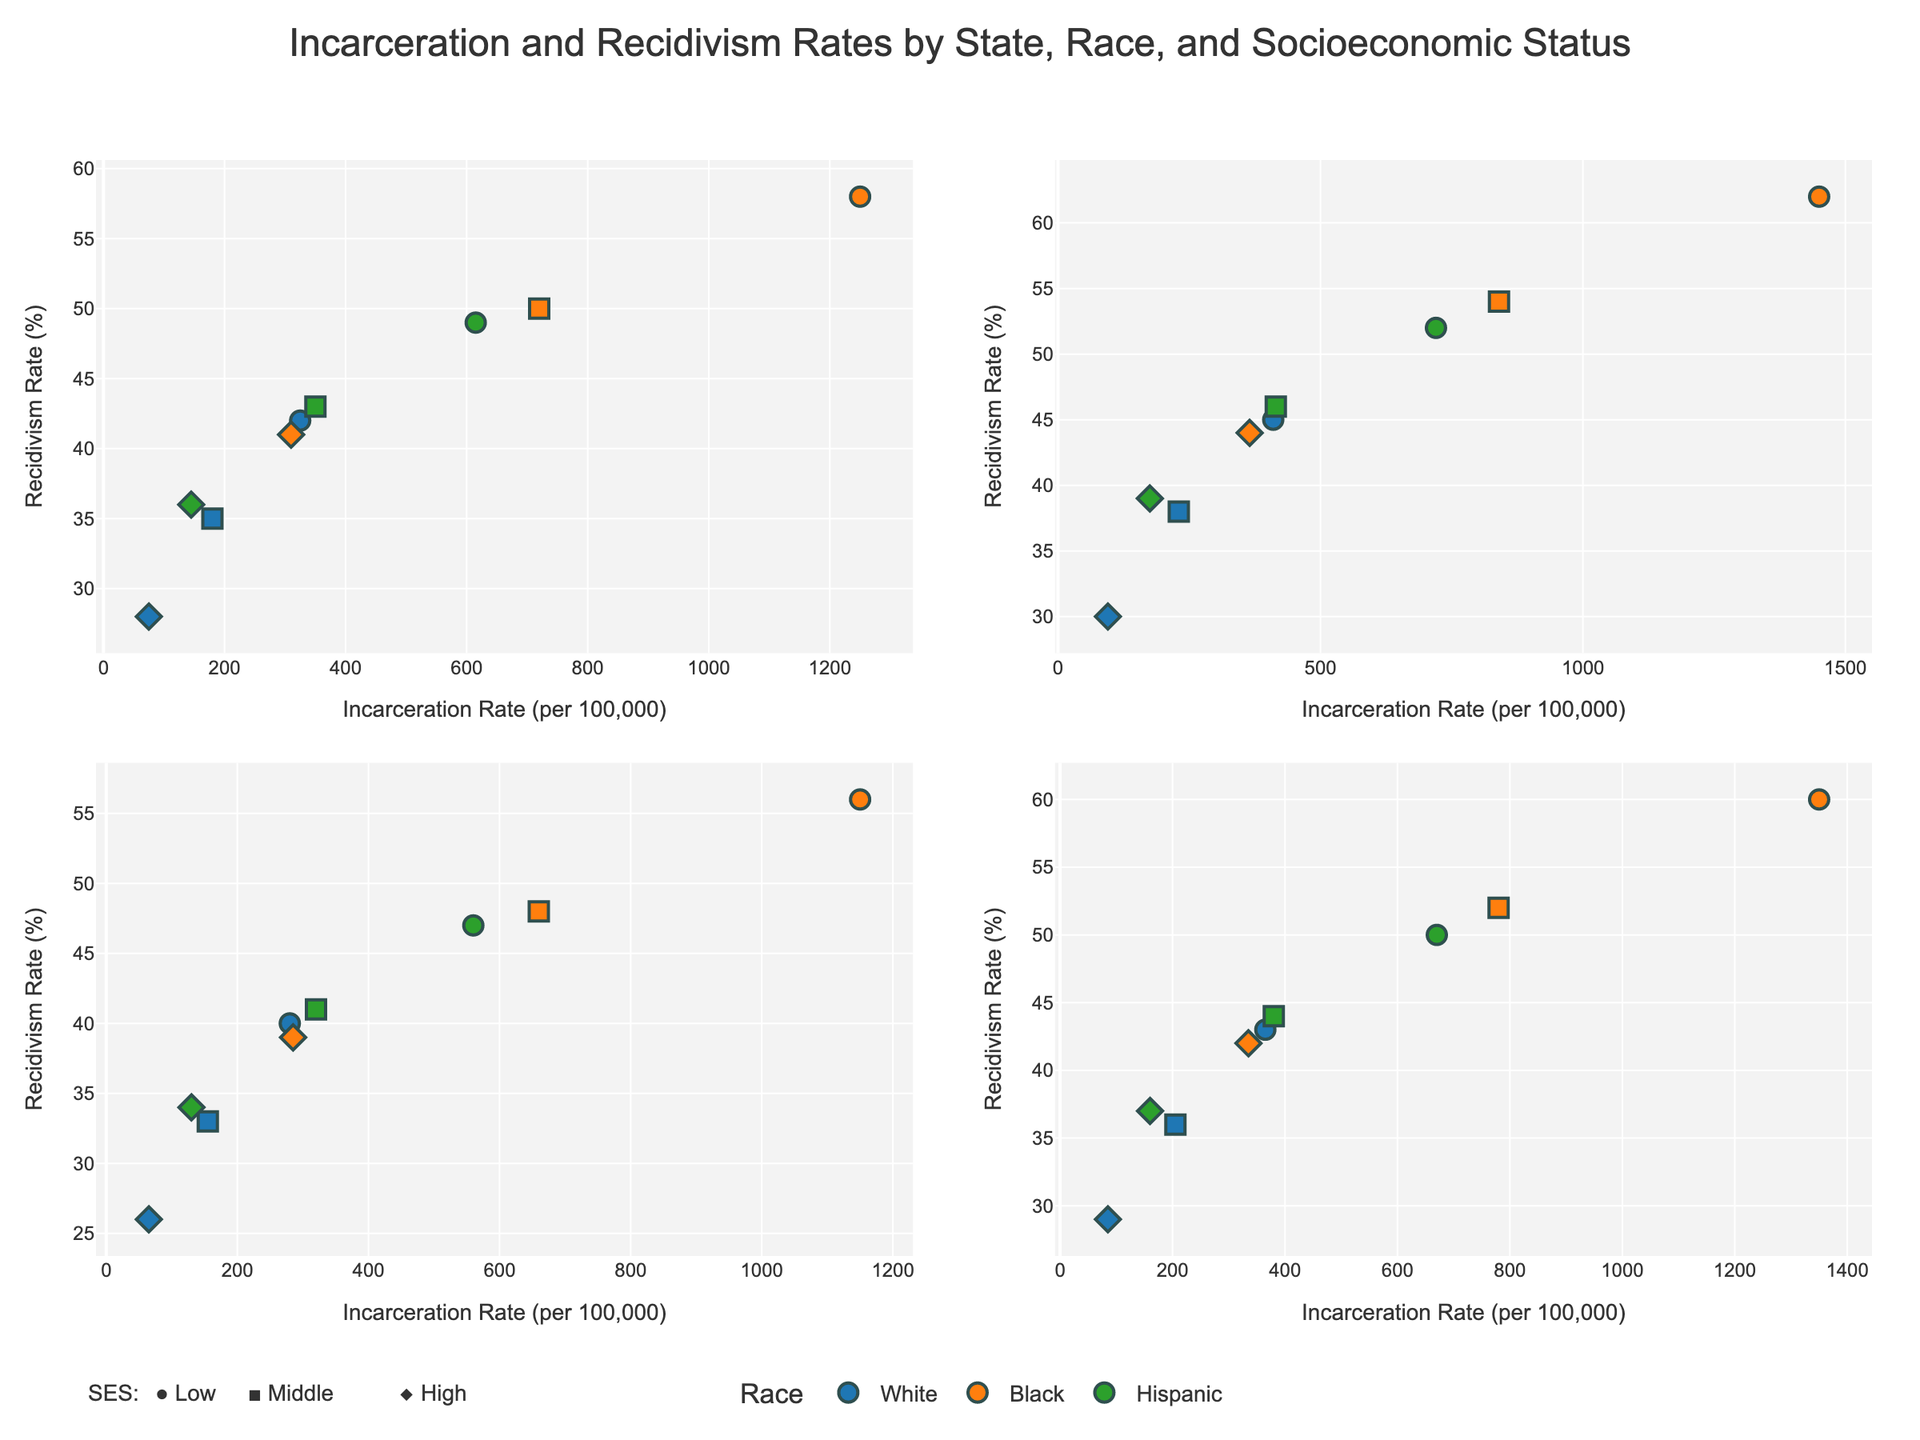What states are included in the figure? Each subplot represents a state, and the subplot titles indicate the states. The states included are California, Texas, New York, and Florida.
Answer: California, Texas, New York, Florida What is the incarceration rate range for Black individuals in Texas across different socioeconomic statuses? By looking at the x-axis values for Black individuals in the Texas subplot, the incarceration rates range from around 365 (High SES) to 1450 (Low SES).
Answer: 365 to 1450 Which race has the highest Recidivism Rate within a single state and socioeconomic status category? According to the y-axis values, for Black individuals in Texas with Low SES, the recidivism rate is 62%, which is the highest among all the combinations.
Answer: Black in Texas with Low SES How do the recidivism rates for White individuals in California compare to those in Florida? By comparing the y-axis values for the White race in the California and Florida subplots, the recidivism rates for Californians are 42% (Low SES), 35% (Middle SES), and 28% (High SES), while for Floridians, they are 43% (Low SES), 36% (Middle SES), and 29% (High SES).
Answer: Similar, with slight differences What's the relationship between incarceration rates and recidivism rates for Hispanic individuals in New York? In the New York subplot, for Hispanic individuals, the incarceration rate and recidivism rates show a decreasing trend from low to high SES. For Low SES, it’s (560, 47%), for Middle SES, it's (320, 41%), and for High SES, it's (130, 34%).
Answer: Both decrease as SES increases What is the average recidivism rate for Black individuals across all SES levels in New York? The recidivism rates for Black individuals in New York are 56% (Low SES), 48% (Middle SES), and 39% (High SES). The average is calculated as (56 + 48 + 39) / 3 = 143 / 3.
Answer: 47.67% Which socio-economic status in California has the lowest incarceration rate, and for which race? By reviewing the California subplot, the lowest incarceration rate is for White individuals with High SES (75 per 100,000).
Answer: White, High SES How does the recidivism rate for Hispanic individuals with Middle SES in Texas compare to those in California? By comparing the y-axis values, the recidivism rate for Hispanic individuals with Middle SES is 46% in Texas and 43% in California.
Answer: Higher in Texas What are the different marker symbols used in the figure, and what do they represent? The marker symbols differ by SES: circles represent Low SES, squares represent Middle SES, and diamonds represent High SES.
Answer: Circles: Low SES, Squares: Middle SES, Diamonds: High SES 